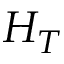Convert formula to latex. <formula><loc_0><loc_0><loc_500><loc_500>H _ { T }</formula> 